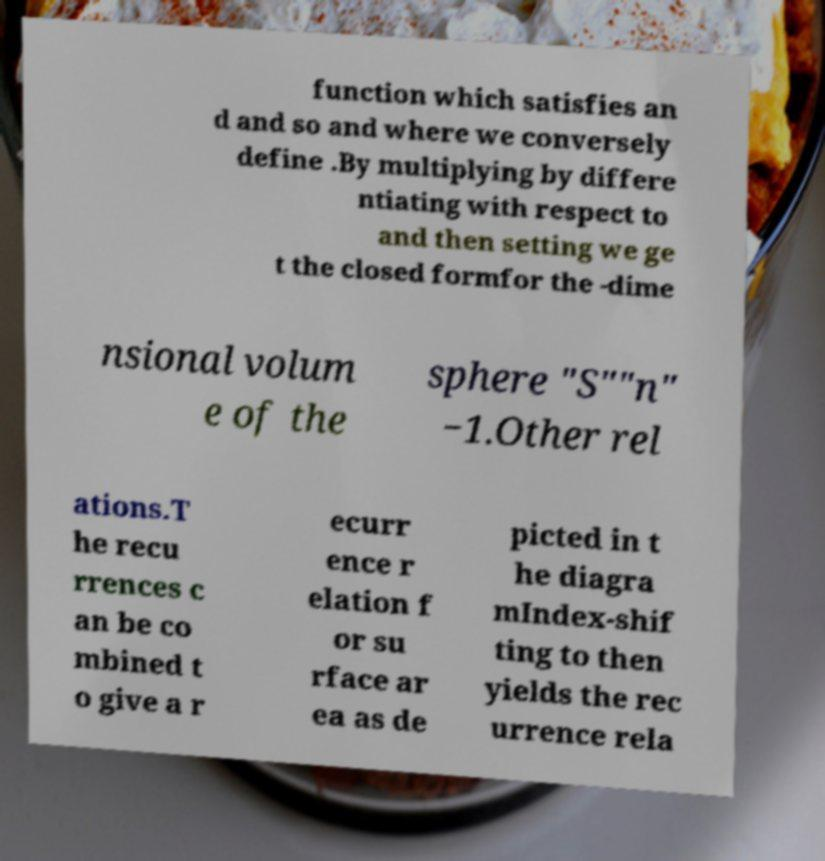Can you read and provide the text displayed in the image?This photo seems to have some interesting text. Can you extract and type it out for me? function which satisfies an d and so and where we conversely define .By multiplying by differe ntiating with respect to and then setting we ge t the closed formfor the -dime nsional volum e of the sphere "S""n" −1.Other rel ations.T he recu rrences c an be co mbined t o give a r ecurr ence r elation f or su rface ar ea as de picted in t he diagra mIndex-shif ting to then yields the rec urrence rela 